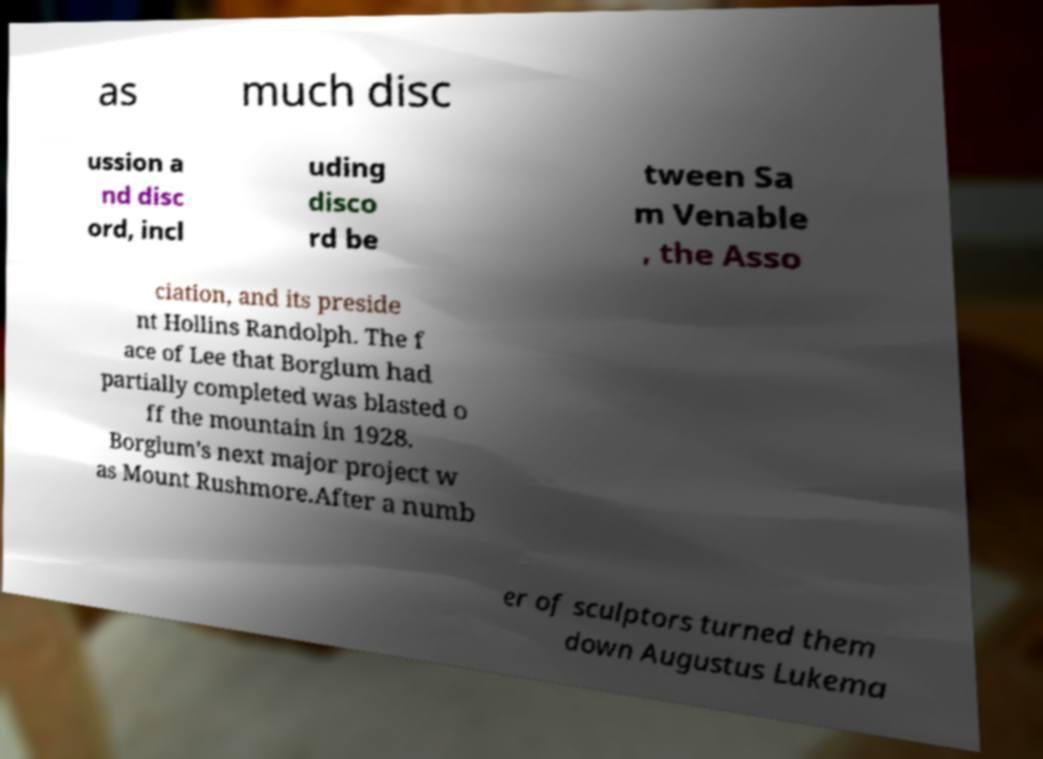I need the written content from this picture converted into text. Can you do that? as much disc ussion a nd disc ord, incl uding disco rd be tween Sa m Venable , the Asso ciation, and its preside nt Hollins Randolph. The f ace of Lee that Borglum had partially completed was blasted o ff the mountain in 1928. Borglum's next major project w as Mount Rushmore.After a numb er of sculptors turned them down Augustus Lukema 